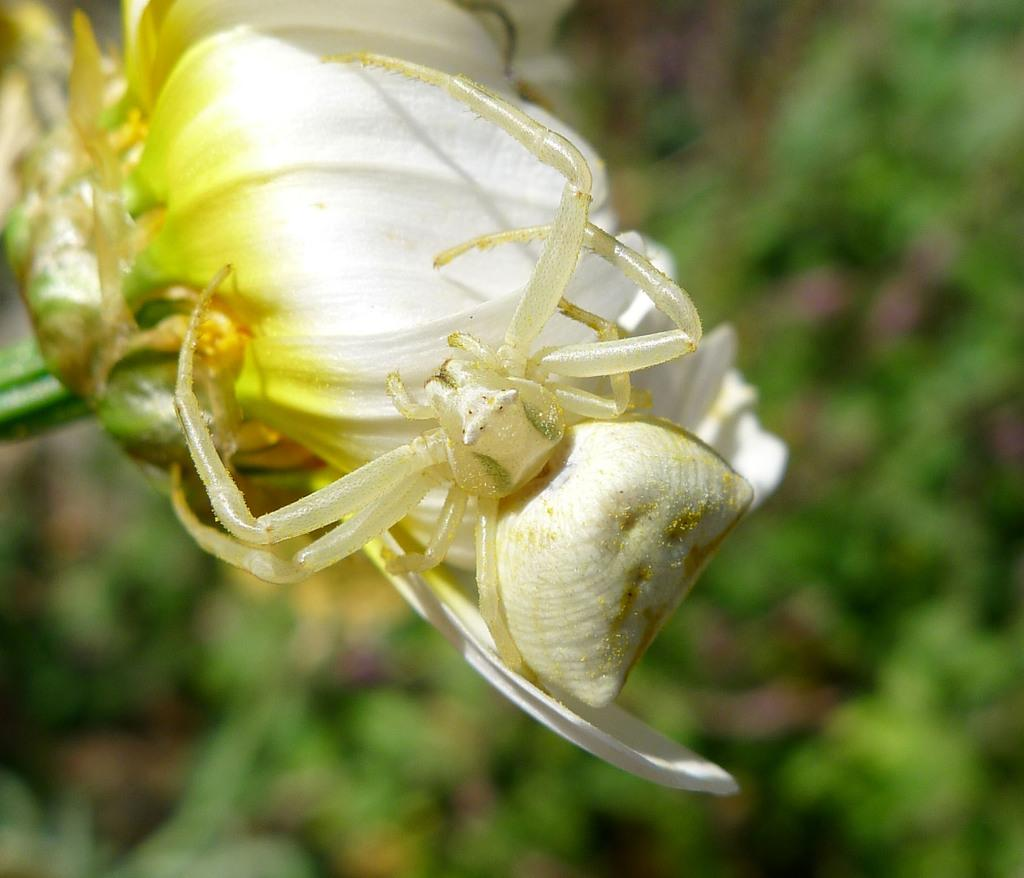What is the main subject of the image? There is a spider in the image. Where is the spider located? The spider is on a flower. What is the color of the spider? The spider is white in color. What can be seen in the background of the image? There are trees visible in the image. What type of feast is the spider attending on the flower in the image? There is no indication of a feast or any gathering in the image; it simply shows a white spider on a flower. Is the spider wearing a mitten in the image? Spiders do not wear mittens, and there is no mitten visible in the image. 